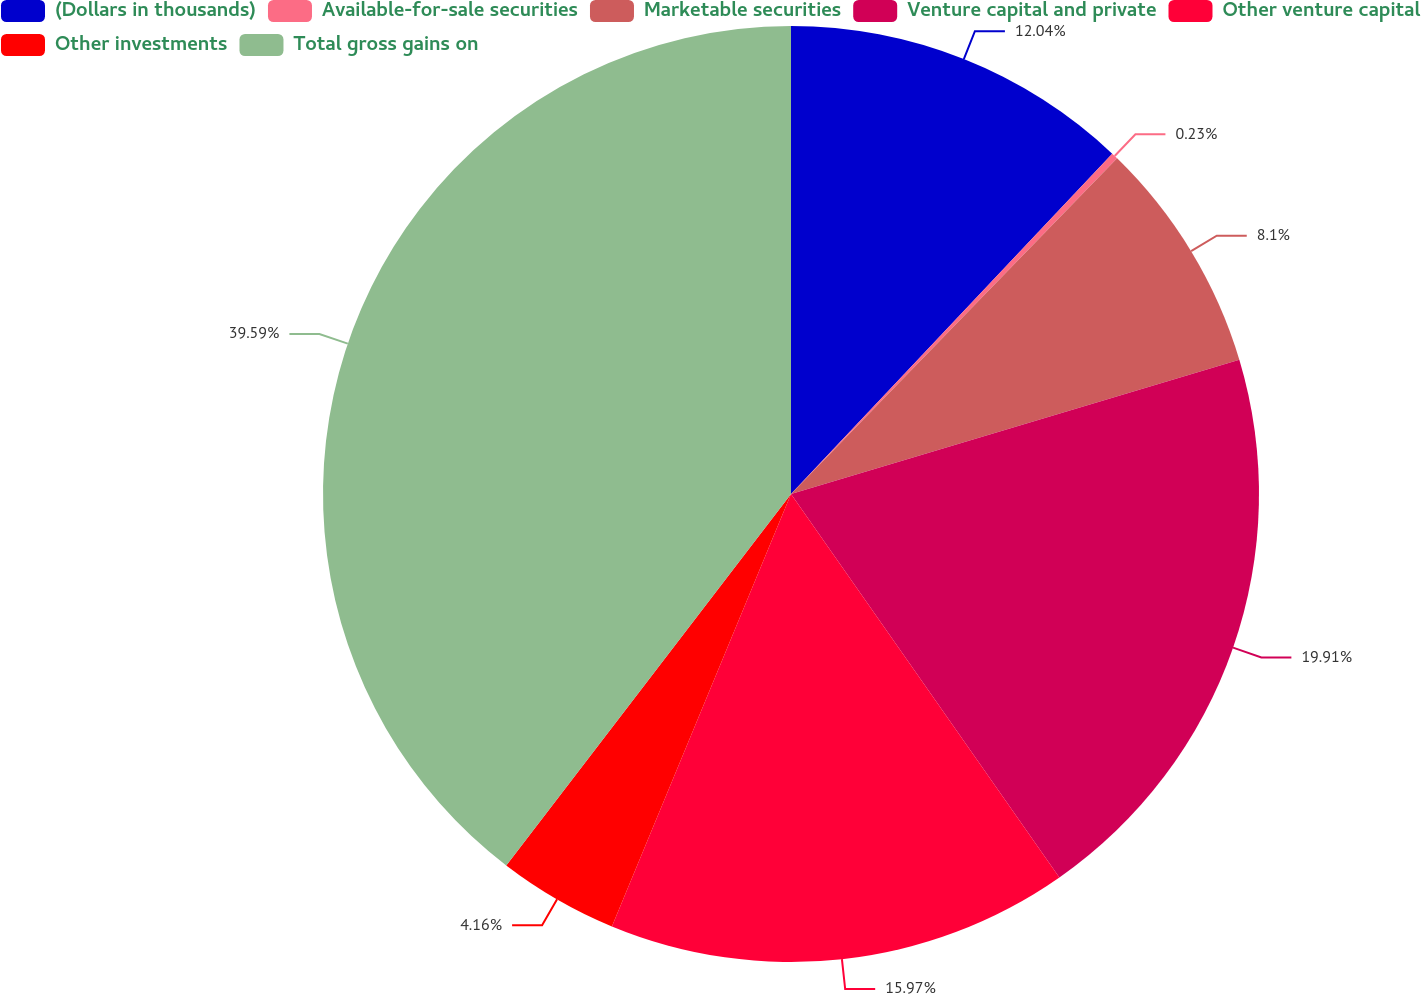Convert chart to OTSL. <chart><loc_0><loc_0><loc_500><loc_500><pie_chart><fcel>(Dollars in thousands)<fcel>Available-for-sale securities<fcel>Marketable securities<fcel>Venture capital and private<fcel>Other venture capital<fcel>Other investments<fcel>Total gross gains on<nl><fcel>12.04%<fcel>0.23%<fcel>8.1%<fcel>19.91%<fcel>15.97%<fcel>4.16%<fcel>39.59%<nl></chart> 